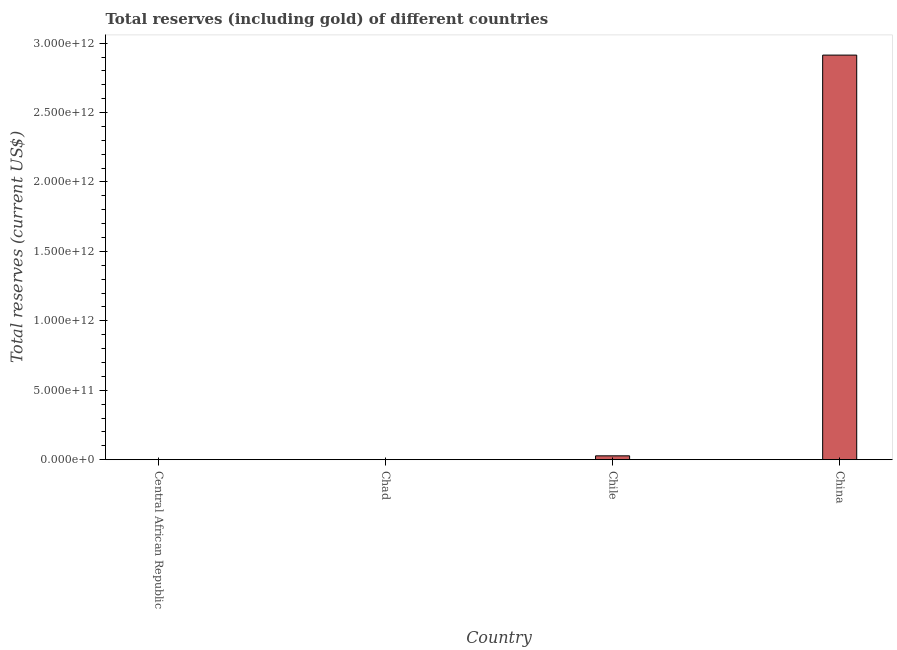Does the graph contain any zero values?
Keep it short and to the point. No. Does the graph contain grids?
Your response must be concise. No. What is the title of the graph?
Your answer should be compact. Total reserves (including gold) of different countries. What is the label or title of the X-axis?
Your answer should be compact. Country. What is the label or title of the Y-axis?
Your answer should be very brief. Total reserves (current US$). What is the total reserves (including gold) in Chad?
Give a very brief answer. 6.32e+08. Across all countries, what is the maximum total reserves (including gold)?
Provide a succinct answer. 2.91e+12. Across all countries, what is the minimum total reserves (including gold)?
Offer a very short reply. 1.81e+08. In which country was the total reserves (including gold) minimum?
Provide a short and direct response. Central African Republic. What is the sum of the total reserves (including gold)?
Offer a very short reply. 2.94e+12. What is the difference between the total reserves (including gold) in Chile and China?
Keep it short and to the point. -2.89e+12. What is the average total reserves (including gold) per country?
Your answer should be compact. 7.36e+11. What is the median total reserves (including gold)?
Provide a short and direct response. 1.42e+1. What is the ratio of the total reserves (including gold) in Central African Republic to that in Chile?
Make the answer very short. 0.01. Is the total reserves (including gold) in Central African Republic less than that in China?
Offer a terse response. Yes. Is the difference between the total reserves (including gold) in Central African Republic and China greater than the difference between any two countries?
Your answer should be compact. Yes. What is the difference between the highest and the second highest total reserves (including gold)?
Ensure brevity in your answer.  2.89e+12. Is the sum of the total reserves (including gold) in Central African Republic and China greater than the maximum total reserves (including gold) across all countries?
Ensure brevity in your answer.  Yes. What is the difference between the highest and the lowest total reserves (including gold)?
Provide a succinct answer. 2.91e+12. How many bars are there?
Offer a terse response. 4. Are all the bars in the graph horizontal?
Keep it short and to the point. No. How many countries are there in the graph?
Provide a succinct answer. 4. What is the difference between two consecutive major ticks on the Y-axis?
Your response must be concise. 5.00e+11. Are the values on the major ticks of Y-axis written in scientific E-notation?
Your answer should be compact. Yes. What is the Total reserves (current US$) of Central African Republic?
Make the answer very short. 1.81e+08. What is the Total reserves (current US$) in Chad?
Ensure brevity in your answer.  6.32e+08. What is the Total reserves (current US$) of Chile?
Your answer should be very brief. 2.78e+1. What is the Total reserves (current US$) in China?
Your response must be concise. 2.91e+12. What is the difference between the Total reserves (current US$) in Central African Republic and Chad?
Make the answer very short. -4.51e+08. What is the difference between the Total reserves (current US$) in Central African Republic and Chile?
Your response must be concise. -2.76e+1. What is the difference between the Total reserves (current US$) in Central African Republic and China?
Provide a short and direct response. -2.91e+12. What is the difference between the Total reserves (current US$) in Chad and Chile?
Your response must be concise. -2.72e+1. What is the difference between the Total reserves (current US$) in Chad and China?
Provide a short and direct response. -2.91e+12. What is the difference between the Total reserves (current US$) in Chile and China?
Offer a very short reply. -2.89e+12. What is the ratio of the Total reserves (current US$) in Central African Republic to that in Chad?
Give a very brief answer. 0.29. What is the ratio of the Total reserves (current US$) in Central African Republic to that in Chile?
Keep it short and to the point. 0.01. What is the ratio of the Total reserves (current US$) in Central African Republic to that in China?
Give a very brief answer. 0. What is the ratio of the Total reserves (current US$) in Chad to that in Chile?
Your answer should be compact. 0.02. 